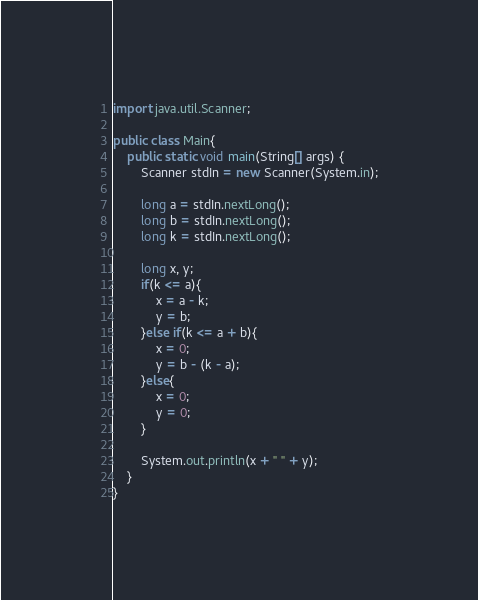<code> <loc_0><loc_0><loc_500><loc_500><_Java_>import java.util.Scanner;

public class Main{
    public static void main(String[] args) {
        Scanner stdIn = new Scanner(System.in);

        long a = stdIn.nextLong();
        long b = stdIn.nextLong();
        long k = stdIn.nextLong();

        long x, y;
        if(k <= a){
            x = a - k;
            y = b;
        }else if(k <= a + b){
            x = 0;
            y = b - (k - a);
        }else{
            x = 0;
            y = 0;
        }

        System.out.println(x + " " + y);
    }
}</code> 